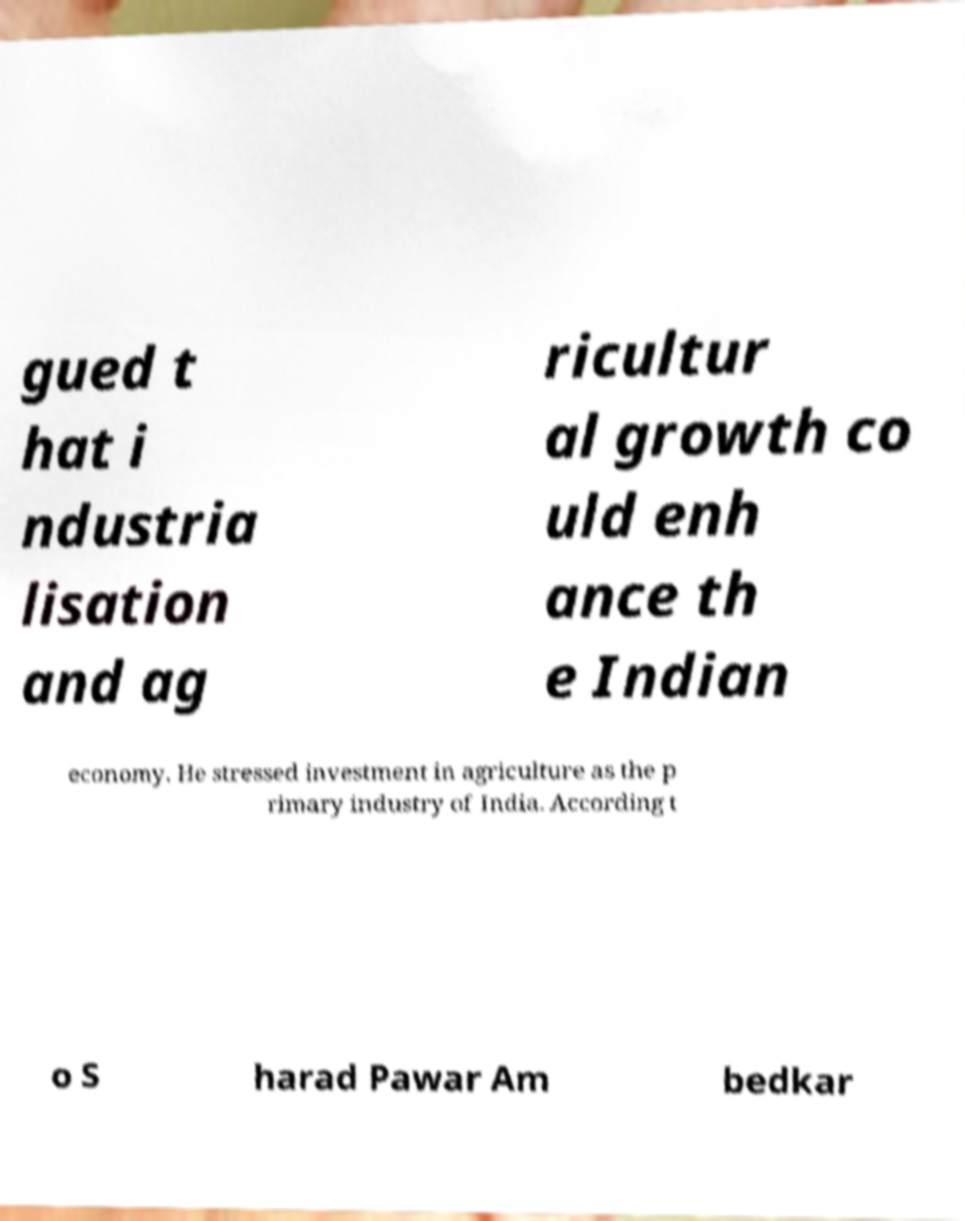Please read and relay the text visible in this image. What does it say? gued t hat i ndustria lisation and ag ricultur al growth co uld enh ance th e Indian economy. He stressed investment in agriculture as the p rimary industry of India. According t o S harad Pawar Am bedkar 